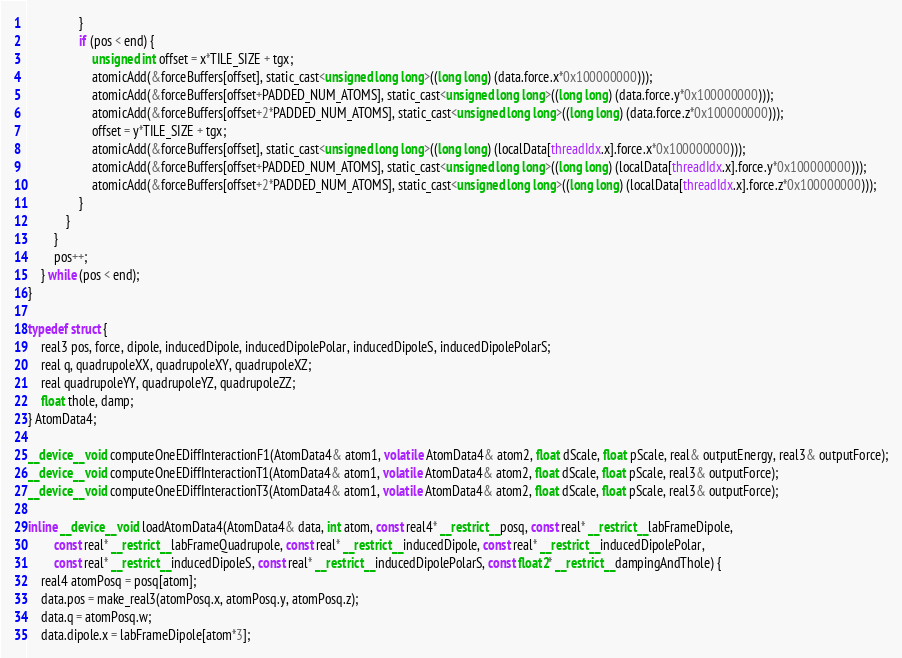Convert code to text. <code><loc_0><loc_0><loc_500><loc_500><_Cuda_>                }
                if (pos < end) {
                    unsigned int offset = x*TILE_SIZE + tgx;
                    atomicAdd(&forceBuffers[offset], static_cast<unsigned long long>((long long) (data.force.x*0x100000000)));
                    atomicAdd(&forceBuffers[offset+PADDED_NUM_ATOMS], static_cast<unsigned long long>((long long) (data.force.y*0x100000000)));
                    atomicAdd(&forceBuffers[offset+2*PADDED_NUM_ATOMS], static_cast<unsigned long long>((long long) (data.force.z*0x100000000)));
                    offset = y*TILE_SIZE + tgx;
                    atomicAdd(&forceBuffers[offset], static_cast<unsigned long long>((long long) (localData[threadIdx.x].force.x*0x100000000)));
                    atomicAdd(&forceBuffers[offset+PADDED_NUM_ATOMS], static_cast<unsigned long long>((long long) (localData[threadIdx.x].force.y*0x100000000)));
                    atomicAdd(&forceBuffers[offset+2*PADDED_NUM_ATOMS], static_cast<unsigned long long>((long long) (localData[threadIdx.x].force.z*0x100000000)));
                }
            }
        }
        pos++;
    } while (pos < end);
}

typedef struct {
    real3 pos, force, dipole, inducedDipole, inducedDipolePolar, inducedDipoleS, inducedDipolePolarS;
    real q, quadrupoleXX, quadrupoleXY, quadrupoleXZ;
    real quadrupoleYY, quadrupoleYZ, quadrupoleZZ;
    float thole, damp;
} AtomData4;

__device__ void computeOneEDiffInteractionF1(AtomData4& atom1, volatile AtomData4& atom2, float dScale, float pScale, real& outputEnergy, real3& outputForce);
__device__ void computeOneEDiffInteractionT1(AtomData4& atom1, volatile AtomData4& atom2, float dScale, float pScale, real3& outputForce);
__device__ void computeOneEDiffInteractionT3(AtomData4& atom1, volatile AtomData4& atom2, float dScale, float pScale, real3& outputForce);

inline __device__ void loadAtomData4(AtomData4& data, int atom, const real4* __restrict__ posq, const real* __restrict__ labFrameDipole,
        const real* __restrict__ labFrameQuadrupole, const real* __restrict__ inducedDipole, const real* __restrict__ inducedDipolePolar,
        const real* __restrict__ inducedDipoleS, const real* __restrict__ inducedDipolePolarS, const float2* __restrict__ dampingAndThole) {
    real4 atomPosq = posq[atom];
    data.pos = make_real3(atomPosq.x, atomPosq.y, atomPosq.z);
    data.q = atomPosq.w;
    data.dipole.x = labFrameDipole[atom*3];</code> 